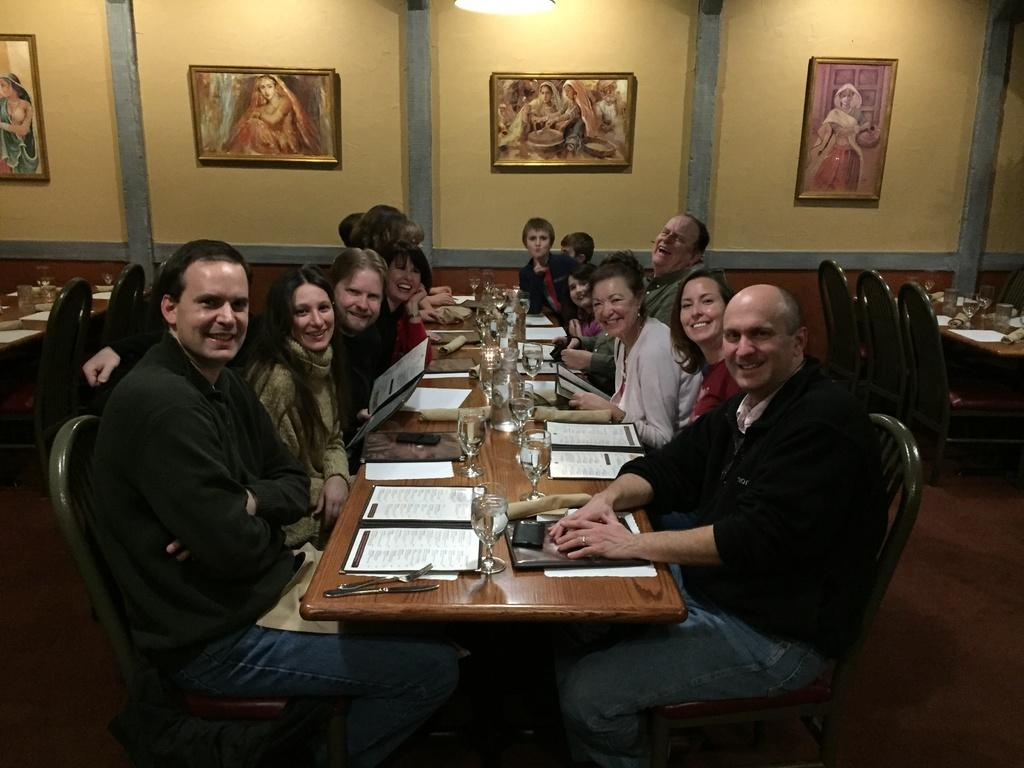What are the people in the image doing? There is a group of people sitting on chairs. What objects can be seen on the table in the image? There is a spoon, a menu-card, and a glass on the table. What is the appearance of the wall in the image? There is a wall without frames in the image. What type of bait is being used by the people sitting on chairs? There is no mention of bait or fishing in the image, so it cannot be determined. 